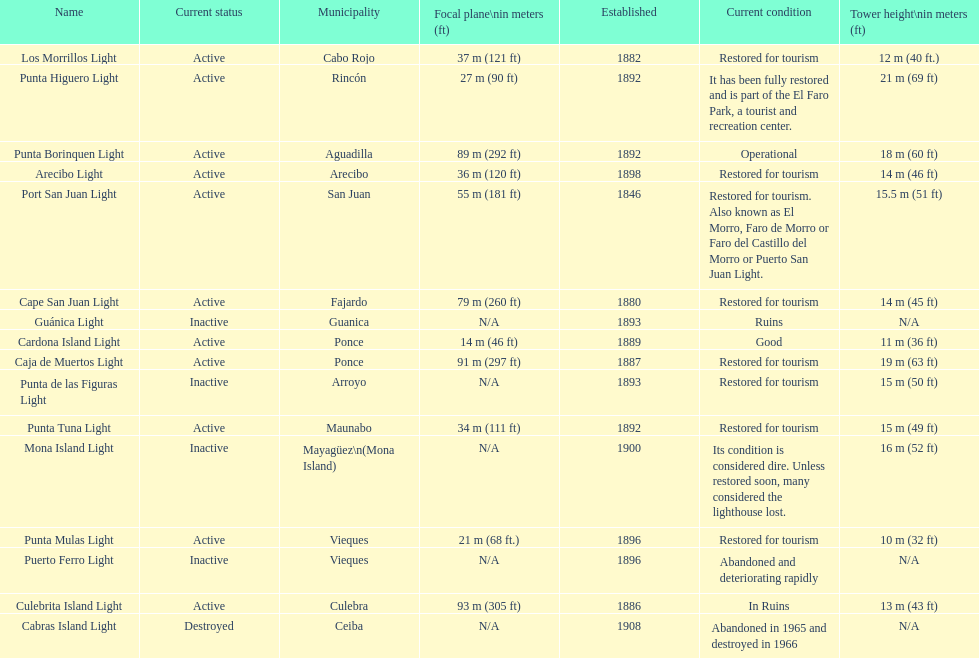Which municipality was the first to be established? San Juan. Could you parse the entire table as a dict? {'header': ['Name', 'Current status', 'Municipality', 'Focal plane\\nin meters (ft)', 'Established', 'Current condition', 'Tower height\\nin meters (ft)'], 'rows': [['Los Morrillos Light', 'Active', 'Cabo Rojo', '37\xa0m (121\xa0ft)', '1882', 'Restored for tourism', '12\xa0m (40\xa0ft.)'], ['Punta Higuero Light', 'Active', 'Rincón', '27\xa0m (90\xa0ft)', '1892', 'It has been fully restored and is part of the El Faro Park, a tourist and recreation center.', '21\xa0m (69\xa0ft)'], ['Punta Borinquen Light', 'Active', 'Aguadilla', '89\xa0m (292\xa0ft)', '1892', 'Operational', '18\xa0m (60\xa0ft)'], ['Arecibo Light', 'Active', 'Arecibo', '36\xa0m (120\xa0ft)', '1898', 'Restored for tourism', '14\xa0m (46\xa0ft)'], ['Port San Juan Light', 'Active', 'San Juan', '55\xa0m (181\xa0ft)', '1846', 'Restored for tourism. Also known as El Morro, Faro de Morro or Faro del Castillo del Morro or Puerto San Juan Light.', '15.5\xa0m (51\xa0ft)'], ['Cape San Juan Light', 'Active', 'Fajardo', '79\xa0m (260\xa0ft)', '1880', 'Restored for tourism', '14\xa0m (45\xa0ft)'], ['Guánica Light', 'Inactive', 'Guanica', 'N/A', '1893', 'Ruins', 'N/A'], ['Cardona Island Light', 'Active', 'Ponce', '14\xa0m (46\xa0ft)', '1889', 'Good', '11\xa0m (36\xa0ft)'], ['Caja de Muertos Light', 'Active', 'Ponce', '91\xa0m (297\xa0ft)', '1887', 'Restored for tourism', '19\xa0m (63\xa0ft)'], ['Punta de las Figuras Light', 'Inactive', 'Arroyo', 'N/A', '1893', 'Restored for tourism', '15\xa0m (50\xa0ft)'], ['Punta Tuna Light', 'Active', 'Maunabo', '34\xa0m (111\xa0ft)', '1892', 'Restored for tourism', '15\xa0m (49\xa0ft)'], ['Mona Island Light', 'Inactive', 'Mayagüez\\n(Mona Island)', 'N/A', '1900', 'Its condition is considered dire. Unless restored soon, many considered the lighthouse lost.', '16\xa0m (52\xa0ft)'], ['Punta Mulas Light', 'Active', 'Vieques', '21\xa0m (68\xa0ft.)', '1896', 'Restored for tourism', '10\xa0m (32\xa0ft)'], ['Puerto Ferro Light', 'Inactive', 'Vieques', 'N/A', '1896', 'Abandoned and deteriorating rapidly', 'N/A'], ['Culebrita Island Light', 'Active', 'Culebra', '93\xa0m (305\xa0ft)', '1886', 'In Ruins', '13\xa0m (43\xa0ft)'], ['Cabras Island Light', 'Destroyed', 'Ceiba', 'N/A', '1908', 'Abandoned in 1965 and destroyed in 1966', 'N/A']]} 